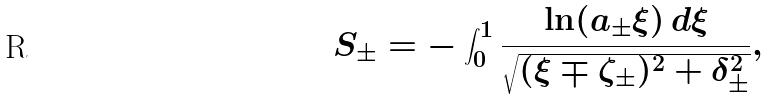<formula> <loc_0><loc_0><loc_500><loc_500>S _ { \pm } = - \int _ { 0 } ^ { 1 } \frac { \ln ( a _ { \pm } \xi ) \, d \xi } { \sqrt { ( \xi \mp \zeta _ { \pm } ) ^ { 2 } + \delta _ { \pm } ^ { 2 } } } ,</formula> 